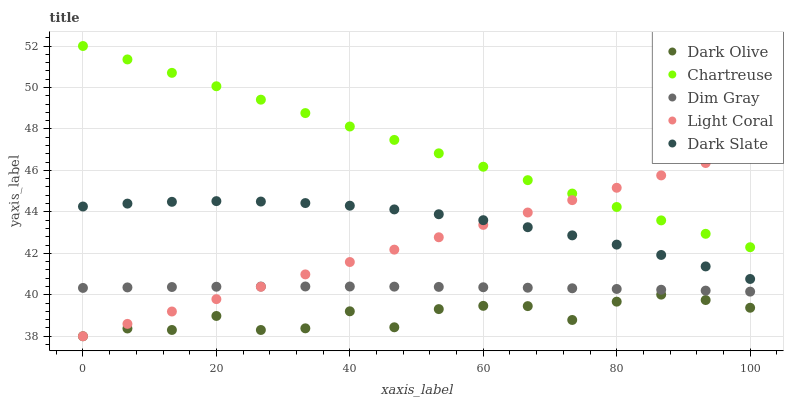Does Dark Olive have the minimum area under the curve?
Answer yes or no. Yes. Does Chartreuse have the maximum area under the curve?
Answer yes or no. Yes. Does Dark Slate have the minimum area under the curve?
Answer yes or no. No. Does Dark Slate have the maximum area under the curve?
Answer yes or no. No. Is Chartreuse the smoothest?
Answer yes or no. Yes. Is Dark Olive the roughest?
Answer yes or no. Yes. Is Dark Slate the smoothest?
Answer yes or no. No. Is Dark Slate the roughest?
Answer yes or no. No. Does Light Coral have the lowest value?
Answer yes or no. Yes. Does Dark Slate have the lowest value?
Answer yes or no. No. Does Chartreuse have the highest value?
Answer yes or no. Yes. Does Dark Slate have the highest value?
Answer yes or no. No. Is Dark Olive less than Dim Gray?
Answer yes or no. Yes. Is Dim Gray greater than Dark Olive?
Answer yes or no. Yes. Does Dark Olive intersect Light Coral?
Answer yes or no. Yes. Is Dark Olive less than Light Coral?
Answer yes or no. No. Is Dark Olive greater than Light Coral?
Answer yes or no. No. Does Dark Olive intersect Dim Gray?
Answer yes or no. No. 